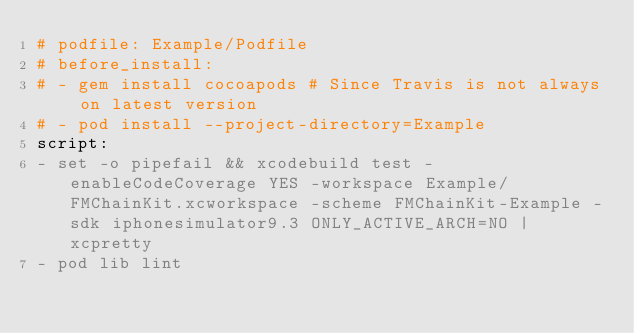Convert code to text. <code><loc_0><loc_0><loc_500><loc_500><_YAML_># podfile: Example/Podfile
# before_install:
# - gem install cocoapods # Since Travis is not always on latest version
# - pod install --project-directory=Example
script:
- set -o pipefail && xcodebuild test -enableCodeCoverage YES -workspace Example/FMChainKit.xcworkspace -scheme FMChainKit-Example -sdk iphonesimulator9.3 ONLY_ACTIVE_ARCH=NO | xcpretty
- pod lib lint
</code> 